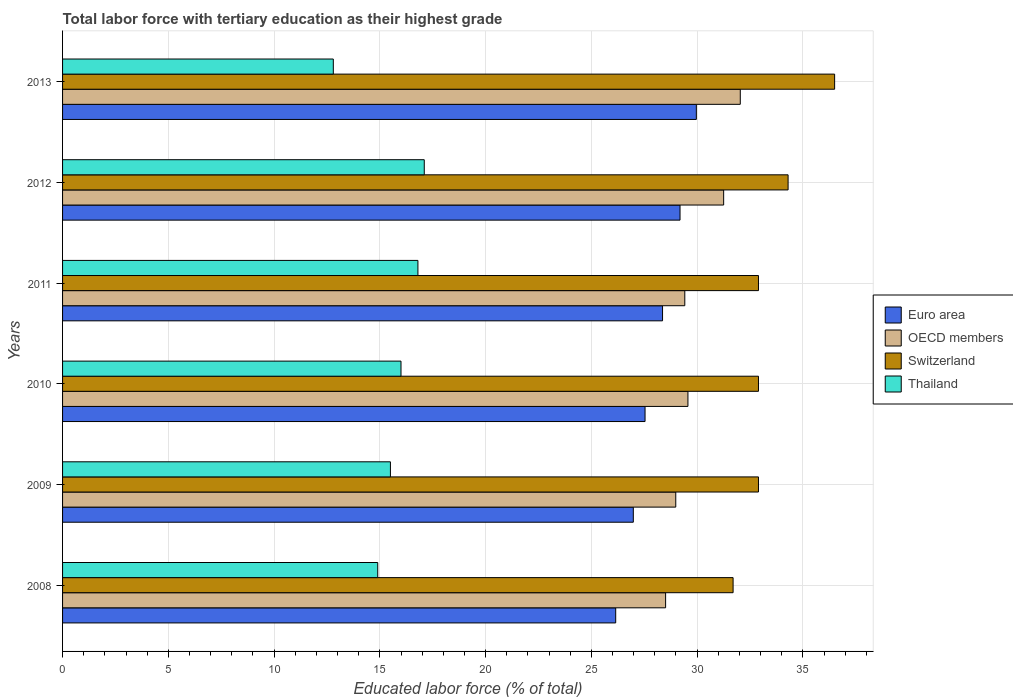How many groups of bars are there?
Your answer should be compact. 6. Are the number of bars on each tick of the Y-axis equal?
Offer a terse response. Yes. How many bars are there on the 6th tick from the top?
Ensure brevity in your answer.  4. How many bars are there on the 2nd tick from the bottom?
Provide a succinct answer. 4. What is the label of the 1st group of bars from the top?
Offer a terse response. 2013. What is the percentage of male labor force with tertiary education in Thailand in 2012?
Your response must be concise. 17.1. Across all years, what is the maximum percentage of male labor force with tertiary education in Thailand?
Keep it short and to the point. 17.1. Across all years, what is the minimum percentage of male labor force with tertiary education in Switzerland?
Give a very brief answer. 31.7. In which year was the percentage of male labor force with tertiary education in Thailand minimum?
Give a very brief answer. 2013. What is the total percentage of male labor force with tertiary education in Euro area in the graph?
Provide a short and direct response. 168.19. What is the difference between the percentage of male labor force with tertiary education in Switzerland in 2009 and that in 2011?
Provide a succinct answer. 0. What is the difference between the percentage of male labor force with tertiary education in Euro area in 2009 and the percentage of male labor force with tertiary education in OECD members in 2012?
Provide a succinct answer. -4.27. What is the average percentage of male labor force with tertiary education in Euro area per year?
Your response must be concise. 28.03. In the year 2011, what is the difference between the percentage of male labor force with tertiary education in Switzerland and percentage of male labor force with tertiary education in Euro area?
Keep it short and to the point. 4.54. In how many years, is the percentage of male labor force with tertiary education in Euro area greater than 21 %?
Your response must be concise. 6. What is the ratio of the percentage of male labor force with tertiary education in OECD members in 2008 to that in 2012?
Give a very brief answer. 0.91. Is the difference between the percentage of male labor force with tertiary education in Switzerland in 2008 and 2009 greater than the difference between the percentage of male labor force with tertiary education in Euro area in 2008 and 2009?
Keep it short and to the point. No. What is the difference between the highest and the second highest percentage of male labor force with tertiary education in Switzerland?
Keep it short and to the point. 2.2. What is the difference between the highest and the lowest percentage of male labor force with tertiary education in Thailand?
Offer a very short reply. 4.3. In how many years, is the percentage of male labor force with tertiary education in OECD members greater than the average percentage of male labor force with tertiary education in OECD members taken over all years?
Give a very brief answer. 2. Is it the case that in every year, the sum of the percentage of male labor force with tertiary education in Switzerland and percentage of male labor force with tertiary education in OECD members is greater than the sum of percentage of male labor force with tertiary education in Thailand and percentage of male labor force with tertiary education in Euro area?
Ensure brevity in your answer.  Yes. What does the 2nd bar from the top in 2010 represents?
Your answer should be very brief. Switzerland. Are all the bars in the graph horizontal?
Keep it short and to the point. Yes. How many years are there in the graph?
Provide a short and direct response. 6. Are the values on the major ticks of X-axis written in scientific E-notation?
Your answer should be very brief. No. Does the graph contain grids?
Offer a terse response. Yes. Where does the legend appear in the graph?
Keep it short and to the point. Center right. How are the legend labels stacked?
Offer a terse response. Vertical. What is the title of the graph?
Provide a succinct answer. Total labor force with tertiary education as their highest grade. What is the label or title of the X-axis?
Give a very brief answer. Educated labor force (% of total). What is the label or title of the Y-axis?
Your answer should be compact. Years. What is the Educated labor force (% of total) of Euro area in 2008?
Provide a short and direct response. 26.15. What is the Educated labor force (% of total) in OECD members in 2008?
Keep it short and to the point. 28.51. What is the Educated labor force (% of total) in Switzerland in 2008?
Offer a very short reply. 31.7. What is the Educated labor force (% of total) in Thailand in 2008?
Make the answer very short. 14.9. What is the Educated labor force (% of total) in Euro area in 2009?
Your response must be concise. 26.98. What is the Educated labor force (% of total) of OECD members in 2009?
Keep it short and to the point. 28.99. What is the Educated labor force (% of total) in Switzerland in 2009?
Keep it short and to the point. 32.9. What is the Educated labor force (% of total) in Thailand in 2009?
Provide a succinct answer. 15.5. What is the Educated labor force (% of total) in Euro area in 2010?
Keep it short and to the point. 27.54. What is the Educated labor force (% of total) of OECD members in 2010?
Your answer should be compact. 29.57. What is the Educated labor force (% of total) of Switzerland in 2010?
Provide a short and direct response. 32.9. What is the Educated labor force (% of total) of Thailand in 2010?
Offer a terse response. 16. What is the Educated labor force (% of total) in Euro area in 2011?
Offer a terse response. 28.36. What is the Educated labor force (% of total) of OECD members in 2011?
Offer a terse response. 29.42. What is the Educated labor force (% of total) in Switzerland in 2011?
Provide a short and direct response. 32.9. What is the Educated labor force (% of total) in Thailand in 2011?
Keep it short and to the point. 16.8. What is the Educated labor force (% of total) in Euro area in 2012?
Give a very brief answer. 29.19. What is the Educated labor force (% of total) of OECD members in 2012?
Give a very brief answer. 31.25. What is the Educated labor force (% of total) of Switzerland in 2012?
Provide a short and direct response. 34.3. What is the Educated labor force (% of total) in Thailand in 2012?
Keep it short and to the point. 17.1. What is the Educated labor force (% of total) of Euro area in 2013?
Offer a terse response. 29.96. What is the Educated labor force (% of total) of OECD members in 2013?
Give a very brief answer. 32.04. What is the Educated labor force (% of total) in Switzerland in 2013?
Keep it short and to the point. 36.5. What is the Educated labor force (% of total) of Thailand in 2013?
Provide a short and direct response. 12.8. Across all years, what is the maximum Educated labor force (% of total) of Euro area?
Provide a short and direct response. 29.96. Across all years, what is the maximum Educated labor force (% of total) of OECD members?
Your answer should be compact. 32.04. Across all years, what is the maximum Educated labor force (% of total) in Switzerland?
Keep it short and to the point. 36.5. Across all years, what is the maximum Educated labor force (% of total) of Thailand?
Offer a very short reply. 17.1. Across all years, what is the minimum Educated labor force (% of total) of Euro area?
Provide a short and direct response. 26.15. Across all years, what is the minimum Educated labor force (% of total) in OECD members?
Make the answer very short. 28.51. Across all years, what is the minimum Educated labor force (% of total) in Switzerland?
Provide a short and direct response. 31.7. Across all years, what is the minimum Educated labor force (% of total) of Thailand?
Your answer should be very brief. 12.8. What is the total Educated labor force (% of total) in Euro area in the graph?
Provide a short and direct response. 168.19. What is the total Educated labor force (% of total) in OECD members in the graph?
Offer a very short reply. 179.77. What is the total Educated labor force (% of total) of Switzerland in the graph?
Ensure brevity in your answer.  201.2. What is the total Educated labor force (% of total) of Thailand in the graph?
Make the answer very short. 93.1. What is the difference between the Educated labor force (% of total) of Euro area in 2008 and that in 2009?
Make the answer very short. -0.83. What is the difference between the Educated labor force (% of total) of OECD members in 2008 and that in 2009?
Provide a short and direct response. -0.48. What is the difference between the Educated labor force (% of total) of Euro area in 2008 and that in 2010?
Offer a very short reply. -1.39. What is the difference between the Educated labor force (% of total) in OECD members in 2008 and that in 2010?
Offer a very short reply. -1.06. What is the difference between the Educated labor force (% of total) of Euro area in 2008 and that in 2011?
Your answer should be very brief. -2.21. What is the difference between the Educated labor force (% of total) of OECD members in 2008 and that in 2011?
Make the answer very short. -0.91. What is the difference between the Educated labor force (% of total) in Switzerland in 2008 and that in 2011?
Ensure brevity in your answer.  -1.2. What is the difference between the Educated labor force (% of total) in Euro area in 2008 and that in 2012?
Offer a terse response. -3.04. What is the difference between the Educated labor force (% of total) of OECD members in 2008 and that in 2012?
Ensure brevity in your answer.  -2.74. What is the difference between the Educated labor force (% of total) of Thailand in 2008 and that in 2012?
Your response must be concise. -2.2. What is the difference between the Educated labor force (% of total) of Euro area in 2008 and that in 2013?
Your response must be concise. -3.81. What is the difference between the Educated labor force (% of total) in OECD members in 2008 and that in 2013?
Your response must be concise. -3.53. What is the difference between the Educated labor force (% of total) in Thailand in 2008 and that in 2013?
Make the answer very short. 2.1. What is the difference between the Educated labor force (% of total) in Euro area in 2009 and that in 2010?
Your answer should be very brief. -0.56. What is the difference between the Educated labor force (% of total) of OECD members in 2009 and that in 2010?
Keep it short and to the point. -0.58. What is the difference between the Educated labor force (% of total) of Switzerland in 2009 and that in 2010?
Provide a short and direct response. 0. What is the difference between the Educated labor force (% of total) of Thailand in 2009 and that in 2010?
Give a very brief answer. -0.5. What is the difference between the Educated labor force (% of total) of Euro area in 2009 and that in 2011?
Your answer should be very brief. -1.38. What is the difference between the Educated labor force (% of total) in OECD members in 2009 and that in 2011?
Provide a succinct answer. -0.43. What is the difference between the Educated labor force (% of total) in Switzerland in 2009 and that in 2011?
Make the answer very short. 0. What is the difference between the Educated labor force (% of total) in Euro area in 2009 and that in 2012?
Give a very brief answer. -2.21. What is the difference between the Educated labor force (% of total) in OECD members in 2009 and that in 2012?
Your response must be concise. -2.26. What is the difference between the Educated labor force (% of total) in Euro area in 2009 and that in 2013?
Provide a succinct answer. -2.98. What is the difference between the Educated labor force (% of total) of OECD members in 2009 and that in 2013?
Keep it short and to the point. -3.05. What is the difference between the Educated labor force (% of total) in Switzerland in 2009 and that in 2013?
Your answer should be very brief. -3.6. What is the difference between the Educated labor force (% of total) of Thailand in 2009 and that in 2013?
Your response must be concise. 2.7. What is the difference between the Educated labor force (% of total) of Euro area in 2010 and that in 2011?
Give a very brief answer. -0.83. What is the difference between the Educated labor force (% of total) in OECD members in 2010 and that in 2011?
Make the answer very short. 0.15. What is the difference between the Educated labor force (% of total) of Switzerland in 2010 and that in 2011?
Give a very brief answer. 0. What is the difference between the Educated labor force (% of total) in Thailand in 2010 and that in 2011?
Give a very brief answer. -0.8. What is the difference between the Educated labor force (% of total) in Euro area in 2010 and that in 2012?
Your answer should be very brief. -1.65. What is the difference between the Educated labor force (% of total) of OECD members in 2010 and that in 2012?
Offer a very short reply. -1.69. What is the difference between the Educated labor force (% of total) in Switzerland in 2010 and that in 2012?
Provide a succinct answer. -1.4. What is the difference between the Educated labor force (% of total) in Thailand in 2010 and that in 2012?
Provide a succinct answer. -1.1. What is the difference between the Educated labor force (% of total) of Euro area in 2010 and that in 2013?
Offer a very short reply. -2.42. What is the difference between the Educated labor force (% of total) of OECD members in 2010 and that in 2013?
Your answer should be compact. -2.47. What is the difference between the Educated labor force (% of total) of Switzerland in 2010 and that in 2013?
Your answer should be very brief. -3.6. What is the difference between the Educated labor force (% of total) of Euro area in 2011 and that in 2012?
Offer a terse response. -0.83. What is the difference between the Educated labor force (% of total) in OECD members in 2011 and that in 2012?
Your answer should be very brief. -1.84. What is the difference between the Educated labor force (% of total) in Switzerland in 2011 and that in 2012?
Offer a terse response. -1.4. What is the difference between the Educated labor force (% of total) of Euro area in 2011 and that in 2013?
Keep it short and to the point. -1.6. What is the difference between the Educated labor force (% of total) in OECD members in 2011 and that in 2013?
Offer a very short reply. -2.62. What is the difference between the Educated labor force (% of total) in Switzerland in 2011 and that in 2013?
Provide a succinct answer. -3.6. What is the difference between the Educated labor force (% of total) in Euro area in 2012 and that in 2013?
Offer a very short reply. -0.77. What is the difference between the Educated labor force (% of total) in OECD members in 2012 and that in 2013?
Offer a very short reply. -0.79. What is the difference between the Educated labor force (% of total) in Switzerland in 2012 and that in 2013?
Your answer should be compact. -2.2. What is the difference between the Educated labor force (% of total) of Thailand in 2012 and that in 2013?
Ensure brevity in your answer.  4.3. What is the difference between the Educated labor force (% of total) in Euro area in 2008 and the Educated labor force (% of total) in OECD members in 2009?
Give a very brief answer. -2.84. What is the difference between the Educated labor force (% of total) of Euro area in 2008 and the Educated labor force (% of total) of Switzerland in 2009?
Offer a terse response. -6.75. What is the difference between the Educated labor force (% of total) in Euro area in 2008 and the Educated labor force (% of total) in Thailand in 2009?
Keep it short and to the point. 10.65. What is the difference between the Educated labor force (% of total) of OECD members in 2008 and the Educated labor force (% of total) of Switzerland in 2009?
Keep it short and to the point. -4.39. What is the difference between the Educated labor force (% of total) of OECD members in 2008 and the Educated labor force (% of total) of Thailand in 2009?
Provide a succinct answer. 13.01. What is the difference between the Educated labor force (% of total) in Euro area in 2008 and the Educated labor force (% of total) in OECD members in 2010?
Your response must be concise. -3.42. What is the difference between the Educated labor force (% of total) of Euro area in 2008 and the Educated labor force (% of total) of Switzerland in 2010?
Provide a short and direct response. -6.75. What is the difference between the Educated labor force (% of total) of Euro area in 2008 and the Educated labor force (% of total) of Thailand in 2010?
Keep it short and to the point. 10.15. What is the difference between the Educated labor force (% of total) in OECD members in 2008 and the Educated labor force (% of total) in Switzerland in 2010?
Make the answer very short. -4.39. What is the difference between the Educated labor force (% of total) in OECD members in 2008 and the Educated labor force (% of total) in Thailand in 2010?
Provide a short and direct response. 12.51. What is the difference between the Educated labor force (% of total) in Euro area in 2008 and the Educated labor force (% of total) in OECD members in 2011?
Your answer should be very brief. -3.27. What is the difference between the Educated labor force (% of total) in Euro area in 2008 and the Educated labor force (% of total) in Switzerland in 2011?
Provide a succinct answer. -6.75. What is the difference between the Educated labor force (% of total) of Euro area in 2008 and the Educated labor force (% of total) of Thailand in 2011?
Your response must be concise. 9.35. What is the difference between the Educated labor force (% of total) of OECD members in 2008 and the Educated labor force (% of total) of Switzerland in 2011?
Make the answer very short. -4.39. What is the difference between the Educated labor force (% of total) of OECD members in 2008 and the Educated labor force (% of total) of Thailand in 2011?
Provide a short and direct response. 11.71. What is the difference between the Educated labor force (% of total) in Switzerland in 2008 and the Educated labor force (% of total) in Thailand in 2011?
Ensure brevity in your answer.  14.9. What is the difference between the Educated labor force (% of total) of Euro area in 2008 and the Educated labor force (% of total) of OECD members in 2012?
Make the answer very short. -5.1. What is the difference between the Educated labor force (% of total) in Euro area in 2008 and the Educated labor force (% of total) in Switzerland in 2012?
Your answer should be compact. -8.15. What is the difference between the Educated labor force (% of total) of Euro area in 2008 and the Educated labor force (% of total) of Thailand in 2012?
Ensure brevity in your answer.  9.05. What is the difference between the Educated labor force (% of total) of OECD members in 2008 and the Educated labor force (% of total) of Switzerland in 2012?
Your response must be concise. -5.79. What is the difference between the Educated labor force (% of total) of OECD members in 2008 and the Educated labor force (% of total) of Thailand in 2012?
Your response must be concise. 11.41. What is the difference between the Educated labor force (% of total) in Euro area in 2008 and the Educated labor force (% of total) in OECD members in 2013?
Make the answer very short. -5.89. What is the difference between the Educated labor force (% of total) in Euro area in 2008 and the Educated labor force (% of total) in Switzerland in 2013?
Offer a terse response. -10.35. What is the difference between the Educated labor force (% of total) in Euro area in 2008 and the Educated labor force (% of total) in Thailand in 2013?
Give a very brief answer. 13.35. What is the difference between the Educated labor force (% of total) of OECD members in 2008 and the Educated labor force (% of total) of Switzerland in 2013?
Your response must be concise. -7.99. What is the difference between the Educated labor force (% of total) in OECD members in 2008 and the Educated labor force (% of total) in Thailand in 2013?
Offer a terse response. 15.71. What is the difference between the Educated labor force (% of total) of Euro area in 2009 and the Educated labor force (% of total) of OECD members in 2010?
Make the answer very short. -2.58. What is the difference between the Educated labor force (% of total) of Euro area in 2009 and the Educated labor force (% of total) of Switzerland in 2010?
Give a very brief answer. -5.92. What is the difference between the Educated labor force (% of total) of Euro area in 2009 and the Educated labor force (% of total) of Thailand in 2010?
Keep it short and to the point. 10.98. What is the difference between the Educated labor force (% of total) of OECD members in 2009 and the Educated labor force (% of total) of Switzerland in 2010?
Your answer should be very brief. -3.91. What is the difference between the Educated labor force (% of total) of OECD members in 2009 and the Educated labor force (% of total) of Thailand in 2010?
Offer a very short reply. 12.99. What is the difference between the Educated labor force (% of total) of Switzerland in 2009 and the Educated labor force (% of total) of Thailand in 2010?
Your answer should be very brief. 16.9. What is the difference between the Educated labor force (% of total) in Euro area in 2009 and the Educated labor force (% of total) in OECD members in 2011?
Your answer should be very brief. -2.43. What is the difference between the Educated labor force (% of total) of Euro area in 2009 and the Educated labor force (% of total) of Switzerland in 2011?
Offer a very short reply. -5.92. What is the difference between the Educated labor force (% of total) in Euro area in 2009 and the Educated labor force (% of total) in Thailand in 2011?
Keep it short and to the point. 10.18. What is the difference between the Educated labor force (% of total) of OECD members in 2009 and the Educated labor force (% of total) of Switzerland in 2011?
Provide a succinct answer. -3.91. What is the difference between the Educated labor force (% of total) of OECD members in 2009 and the Educated labor force (% of total) of Thailand in 2011?
Your response must be concise. 12.19. What is the difference between the Educated labor force (% of total) in Euro area in 2009 and the Educated labor force (% of total) in OECD members in 2012?
Offer a very short reply. -4.27. What is the difference between the Educated labor force (% of total) of Euro area in 2009 and the Educated labor force (% of total) of Switzerland in 2012?
Provide a short and direct response. -7.32. What is the difference between the Educated labor force (% of total) in Euro area in 2009 and the Educated labor force (% of total) in Thailand in 2012?
Your answer should be compact. 9.88. What is the difference between the Educated labor force (% of total) in OECD members in 2009 and the Educated labor force (% of total) in Switzerland in 2012?
Provide a short and direct response. -5.31. What is the difference between the Educated labor force (% of total) of OECD members in 2009 and the Educated labor force (% of total) of Thailand in 2012?
Give a very brief answer. 11.89. What is the difference between the Educated labor force (% of total) in Switzerland in 2009 and the Educated labor force (% of total) in Thailand in 2012?
Provide a short and direct response. 15.8. What is the difference between the Educated labor force (% of total) of Euro area in 2009 and the Educated labor force (% of total) of OECD members in 2013?
Make the answer very short. -5.06. What is the difference between the Educated labor force (% of total) in Euro area in 2009 and the Educated labor force (% of total) in Switzerland in 2013?
Make the answer very short. -9.52. What is the difference between the Educated labor force (% of total) in Euro area in 2009 and the Educated labor force (% of total) in Thailand in 2013?
Your response must be concise. 14.18. What is the difference between the Educated labor force (% of total) in OECD members in 2009 and the Educated labor force (% of total) in Switzerland in 2013?
Ensure brevity in your answer.  -7.51. What is the difference between the Educated labor force (% of total) of OECD members in 2009 and the Educated labor force (% of total) of Thailand in 2013?
Your answer should be very brief. 16.19. What is the difference between the Educated labor force (% of total) in Switzerland in 2009 and the Educated labor force (% of total) in Thailand in 2013?
Your answer should be compact. 20.1. What is the difference between the Educated labor force (% of total) in Euro area in 2010 and the Educated labor force (% of total) in OECD members in 2011?
Provide a succinct answer. -1.88. What is the difference between the Educated labor force (% of total) of Euro area in 2010 and the Educated labor force (% of total) of Switzerland in 2011?
Make the answer very short. -5.36. What is the difference between the Educated labor force (% of total) in Euro area in 2010 and the Educated labor force (% of total) in Thailand in 2011?
Provide a succinct answer. 10.74. What is the difference between the Educated labor force (% of total) in OECD members in 2010 and the Educated labor force (% of total) in Switzerland in 2011?
Your answer should be very brief. -3.33. What is the difference between the Educated labor force (% of total) in OECD members in 2010 and the Educated labor force (% of total) in Thailand in 2011?
Ensure brevity in your answer.  12.77. What is the difference between the Educated labor force (% of total) in Euro area in 2010 and the Educated labor force (% of total) in OECD members in 2012?
Your answer should be compact. -3.72. What is the difference between the Educated labor force (% of total) of Euro area in 2010 and the Educated labor force (% of total) of Switzerland in 2012?
Offer a very short reply. -6.76. What is the difference between the Educated labor force (% of total) in Euro area in 2010 and the Educated labor force (% of total) in Thailand in 2012?
Offer a terse response. 10.44. What is the difference between the Educated labor force (% of total) of OECD members in 2010 and the Educated labor force (% of total) of Switzerland in 2012?
Make the answer very short. -4.73. What is the difference between the Educated labor force (% of total) of OECD members in 2010 and the Educated labor force (% of total) of Thailand in 2012?
Offer a terse response. 12.47. What is the difference between the Educated labor force (% of total) in Euro area in 2010 and the Educated labor force (% of total) in OECD members in 2013?
Provide a succinct answer. -4.5. What is the difference between the Educated labor force (% of total) in Euro area in 2010 and the Educated labor force (% of total) in Switzerland in 2013?
Offer a terse response. -8.96. What is the difference between the Educated labor force (% of total) of Euro area in 2010 and the Educated labor force (% of total) of Thailand in 2013?
Ensure brevity in your answer.  14.74. What is the difference between the Educated labor force (% of total) of OECD members in 2010 and the Educated labor force (% of total) of Switzerland in 2013?
Your answer should be compact. -6.93. What is the difference between the Educated labor force (% of total) in OECD members in 2010 and the Educated labor force (% of total) in Thailand in 2013?
Offer a terse response. 16.77. What is the difference between the Educated labor force (% of total) of Switzerland in 2010 and the Educated labor force (% of total) of Thailand in 2013?
Provide a succinct answer. 20.1. What is the difference between the Educated labor force (% of total) of Euro area in 2011 and the Educated labor force (% of total) of OECD members in 2012?
Your answer should be very brief. -2.89. What is the difference between the Educated labor force (% of total) of Euro area in 2011 and the Educated labor force (% of total) of Switzerland in 2012?
Provide a succinct answer. -5.94. What is the difference between the Educated labor force (% of total) of Euro area in 2011 and the Educated labor force (% of total) of Thailand in 2012?
Offer a terse response. 11.26. What is the difference between the Educated labor force (% of total) in OECD members in 2011 and the Educated labor force (% of total) in Switzerland in 2012?
Ensure brevity in your answer.  -4.88. What is the difference between the Educated labor force (% of total) of OECD members in 2011 and the Educated labor force (% of total) of Thailand in 2012?
Offer a very short reply. 12.32. What is the difference between the Educated labor force (% of total) of Switzerland in 2011 and the Educated labor force (% of total) of Thailand in 2012?
Make the answer very short. 15.8. What is the difference between the Educated labor force (% of total) in Euro area in 2011 and the Educated labor force (% of total) in OECD members in 2013?
Ensure brevity in your answer.  -3.67. What is the difference between the Educated labor force (% of total) in Euro area in 2011 and the Educated labor force (% of total) in Switzerland in 2013?
Provide a short and direct response. -8.14. What is the difference between the Educated labor force (% of total) in Euro area in 2011 and the Educated labor force (% of total) in Thailand in 2013?
Keep it short and to the point. 15.56. What is the difference between the Educated labor force (% of total) of OECD members in 2011 and the Educated labor force (% of total) of Switzerland in 2013?
Give a very brief answer. -7.08. What is the difference between the Educated labor force (% of total) in OECD members in 2011 and the Educated labor force (% of total) in Thailand in 2013?
Your answer should be very brief. 16.62. What is the difference between the Educated labor force (% of total) of Switzerland in 2011 and the Educated labor force (% of total) of Thailand in 2013?
Offer a very short reply. 20.1. What is the difference between the Educated labor force (% of total) of Euro area in 2012 and the Educated labor force (% of total) of OECD members in 2013?
Give a very brief answer. -2.85. What is the difference between the Educated labor force (% of total) in Euro area in 2012 and the Educated labor force (% of total) in Switzerland in 2013?
Keep it short and to the point. -7.31. What is the difference between the Educated labor force (% of total) in Euro area in 2012 and the Educated labor force (% of total) in Thailand in 2013?
Offer a very short reply. 16.39. What is the difference between the Educated labor force (% of total) of OECD members in 2012 and the Educated labor force (% of total) of Switzerland in 2013?
Give a very brief answer. -5.25. What is the difference between the Educated labor force (% of total) in OECD members in 2012 and the Educated labor force (% of total) in Thailand in 2013?
Give a very brief answer. 18.45. What is the average Educated labor force (% of total) of Euro area per year?
Give a very brief answer. 28.03. What is the average Educated labor force (% of total) in OECD members per year?
Ensure brevity in your answer.  29.96. What is the average Educated labor force (% of total) in Switzerland per year?
Keep it short and to the point. 33.53. What is the average Educated labor force (% of total) in Thailand per year?
Keep it short and to the point. 15.52. In the year 2008, what is the difference between the Educated labor force (% of total) in Euro area and Educated labor force (% of total) in OECD members?
Provide a short and direct response. -2.36. In the year 2008, what is the difference between the Educated labor force (% of total) in Euro area and Educated labor force (% of total) in Switzerland?
Offer a very short reply. -5.55. In the year 2008, what is the difference between the Educated labor force (% of total) of Euro area and Educated labor force (% of total) of Thailand?
Give a very brief answer. 11.25. In the year 2008, what is the difference between the Educated labor force (% of total) in OECD members and Educated labor force (% of total) in Switzerland?
Your answer should be compact. -3.19. In the year 2008, what is the difference between the Educated labor force (% of total) of OECD members and Educated labor force (% of total) of Thailand?
Your answer should be compact. 13.61. In the year 2008, what is the difference between the Educated labor force (% of total) in Switzerland and Educated labor force (% of total) in Thailand?
Provide a short and direct response. 16.8. In the year 2009, what is the difference between the Educated labor force (% of total) of Euro area and Educated labor force (% of total) of OECD members?
Your answer should be compact. -2.01. In the year 2009, what is the difference between the Educated labor force (% of total) in Euro area and Educated labor force (% of total) in Switzerland?
Offer a very short reply. -5.92. In the year 2009, what is the difference between the Educated labor force (% of total) of Euro area and Educated labor force (% of total) of Thailand?
Provide a short and direct response. 11.48. In the year 2009, what is the difference between the Educated labor force (% of total) in OECD members and Educated labor force (% of total) in Switzerland?
Your answer should be very brief. -3.91. In the year 2009, what is the difference between the Educated labor force (% of total) of OECD members and Educated labor force (% of total) of Thailand?
Offer a terse response. 13.49. In the year 2009, what is the difference between the Educated labor force (% of total) in Switzerland and Educated labor force (% of total) in Thailand?
Provide a succinct answer. 17.4. In the year 2010, what is the difference between the Educated labor force (% of total) of Euro area and Educated labor force (% of total) of OECD members?
Your answer should be compact. -2.03. In the year 2010, what is the difference between the Educated labor force (% of total) in Euro area and Educated labor force (% of total) in Switzerland?
Give a very brief answer. -5.36. In the year 2010, what is the difference between the Educated labor force (% of total) in Euro area and Educated labor force (% of total) in Thailand?
Keep it short and to the point. 11.54. In the year 2010, what is the difference between the Educated labor force (% of total) of OECD members and Educated labor force (% of total) of Switzerland?
Your response must be concise. -3.33. In the year 2010, what is the difference between the Educated labor force (% of total) of OECD members and Educated labor force (% of total) of Thailand?
Your answer should be very brief. 13.57. In the year 2010, what is the difference between the Educated labor force (% of total) of Switzerland and Educated labor force (% of total) of Thailand?
Your response must be concise. 16.9. In the year 2011, what is the difference between the Educated labor force (% of total) of Euro area and Educated labor force (% of total) of OECD members?
Offer a terse response. -1.05. In the year 2011, what is the difference between the Educated labor force (% of total) in Euro area and Educated labor force (% of total) in Switzerland?
Make the answer very short. -4.54. In the year 2011, what is the difference between the Educated labor force (% of total) in Euro area and Educated labor force (% of total) in Thailand?
Offer a very short reply. 11.56. In the year 2011, what is the difference between the Educated labor force (% of total) of OECD members and Educated labor force (% of total) of Switzerland?
Provide a succinct answer. -3.48. In the year 2011, what is the difference between the Educated labor force (% of total) in OECD members and Educated labor force (% of total) in Thailand?
Offer a terse response. 12.62. In the year 2012, what is the difference between the Educated labor force (% of total) in Euro area and Educated labor force (% of total) in OECD members?
Provide a short and direct response. -2.06. In the year 2012, what is the difference between the Educated labor force (% of total) of Euro area and Educated labor force (% of total) of Switzerland?
Provide a short and direct response. -5.11. In the year 2012, what is the difference between the Educated labor force (% of total) of Euro area and Educated labor force (% of total) of Thailand?
Your answer should be very brief. 12.09. In the year 2012, what is the difference between the Educated labor force (% of total) of OECD members and Educated labor force (% of total) of Switzerland?
Offer a very short reply. -3.05. In the year 2012, what is the difference between the Educated labor force (% of total) in OECD members and Educated labor force (% of total) in Thailand?
Offer a very short reply. 14.15. In the year 2012, what is the difference between the Educated labor force (% of total) of Switzerland and Educated labor force (% of total) of Thailand?
Provide a succinct answer. 17.2. In the year 2013, what is the difference between the Educated labor force (% of total) of Euro area and Educated labor force (% of total) of OECD members?
Provide a short and direct response. -2.08. In the year 2013, what is the difference between the Educated labor force (% of total) in Euro area and Educated labor force (% of total) in Switzerland?
Offer a very short reply. -6.54. In the year 2013, what is the difference between the Educated labor force (% of total) in Euro area and Educated labor force (% of total) in Thailand?
Your answer should be compact. 17.16. In the year 2013, what is the difference between the Educated labor force (% of total) in OECD members and Educated labor force (% of total) in Switzerland?
Provide a succinct answer. -4.46. In the year 2013, what is the difference between the Educated labor force (% of total) of OECD members and Educated labor force (% of total) of Thailand?
Provide a succinct answer. 19.24. In the year 2013, what is the difference between the Educated labor force (% of total) in Switzerland and Educated labor force (% of total) in Thailand?
Keep it short and to the point. 23.7. What is the ratio of the Educated labor force (% of total) of Euro area in 2008 to that in 2009?
Offer a terse response. 0.97. What is the ratio of the Educated labor force (% of total) in OECD members in 2008 to that in 2009?
Give a very brief answer. 0.98. What is the ratio of the Educated labor force (% of total) of Switzerland in 2008 to that in 2009?
Offer a terse response. 0.96. What is the ratio of the Educated labor force (% of total) in Thailand in 2008 to that in 2009?
Your answer should be compact. 0.96. What is the ratio of the Educated labor force (% of total) of Euro area in 2008 to that in 2010?
Make the answer very short. 0.95. What is the ratio of the Educated labor force (% of total) of OECD members in 2008 to that in 2010?
Make the answer very short. 0.96. What is the ratio of the Educated labor force (% of total) in Switzerland in 2008 to that in 2010?
Provide a short and direct response. 0.96. What is the ratio of the Educated labor force (% of total) in Thailand in 2008 to that in 2010?
Your answer should be compact. 0.93. What is the ratio of the Educated labor force (% of total) in Euro area in 2008 to that in 2011?
Your answer should be compact. 0.92. What is the ratio of the Educated labor force (% of total) in OECD members in 2008 to that in 2011?
Provide a succinct answer. 0.97. What is the ratio of the Educated labor force (% of total) of Switzerland in 2008 to that in 2011?
Provide a short and direct response. 0.96. What is the ratio of the Educated labor force (% of total) in Thailand in 2008 to that in 2011?
Provide a short and direct response. 0.89. What is the ratio of the Educated labor force (% of total) in Euro area in 2008 to that in 2012?
Give a very brief answer. 0.9. What is the ratio of the Educated labor force (% of total) of OECD members in 2008 to that in 2012?
Give a very brief answer. 0.91. What is the ratio of the Educated labor force (% of total) of Switzerland in 2008 to that in 2012?
Your response must be concise. 0.92. What is the ratio of the Educated labor force (% of total) in Thailand in 2008 to that in 2012?
Your response must be concise. 0.87. What is the ratio of the Educated labor force (% of total) in Euro area in 2008 to that in 2013?
Your answer should be compact. 0.87. What is the ratio of the Educated labor force (% of total) in OECD members in 2008 to that in 2013?
Your answer should be very brief. 0.89. What is the ratio of the Educated labor force (% of total) in Switzerland in 2008 to that in 2013?
Your answer should be compact. 0.87. What is the ratio of the Educated labor force (% of total) in Thailand in 2008 to that in 2013?
Ensure brevity in your answer.  1.16. What is the ratio of the Educated labor force (% of total) in Euro area in 2009 to that in 2010?
Give a very brief answer. 0.98. What is the ratio of the Educated labor force (% of total) of OECD members in 2009 to that in 2010?
Your response must be concise. 0.98. What is the ratio of the Educated labor force (% of total) of Thailand in 2009 to that in 2010?
Provide a succinct answer. 0.97. What is the ratio of the Educated labor force (% of total) in Euro area in 2009 to that in 2011?
Your response must be concise. 0.95. What is the ratio of the Educated labor force (% of total) of OECD members in 2009 to that in 2011?
Ensure brevity in your answer.  0.99. What is the ratio of the Educated labor force (% of total) of Switzerland in 2009 to that in 2011?
Offer a very short reply. 1. What is the ratio of the Educated labor force (% of total) of Thailand in 2009 to that in 2011?
Keep it short and to the point. 0.92. What is the ratio of the Educated labor force (% of total) of Euro area in 2009 to that in 2012?
Provide a succinct answer. 0.92. What is the ratio of the Educated labor force (% of total) in OECD members in 2009 to that in 2012?
Your response must be concise. 0.93. What is the ratio of the Educated labor force (% of total) of Switzerland in 2009 to that in 2012?
Make the answer very short. 0.96. What is the ratio of the Educated labor force (% of total) in Thailand in 2009 to that in 2012?
Provide a short and direct response. 0.91. What is the ratio of the Educated labor force (% of total) of Euro area in 2009 to that in 2013?
Offer a terse response. 0.9. What is the ratio of the Educated labor force (% of total) in OECD members in 2009 to that in 2013?
Provide a short and direct response. 0.9. What is the ratio of the Educated labor force (% of total) of Switzerland in 2009 to that in 2013?
Your answer should be compact. 0.9. What is the ratio of the Educated labor force (% of total) in Thailand in 2009 to that in 2013?
Provide a succinct answer. 1.21. What is the ratio of the Educated labor force (% of total) of Euro area in 2010 to that in 2011?
Your answer should be very brief. 0.97. What is the ratio of the Educated labor force (% of total) of Euro area in 2010 to that in 2012?
Give a very brief answer. 0.94. What is the ratio of the Educated labor force (% of total) of OECD members in 2010 to that in 2012?
Provide a succinct answer. 0.95. What is the ratio of the Educated labor force (% of total) in Switzerland in 2010 to that in 2012?
Provide a short and direct response. 0.96. What is the ratio of the Educated labor force (% of total) in Thailand in 2010 to that in 2012?
Your response must be concise. 0.94. What is the ratio of the Educated labor force (% of total) in Euro area in 2010 to that in 2013?
Provide a short and direct response. 0.92. What is the ratio of the Educated labor force (% of total) in OECD members in 2010 to that in 2013?
Ensure brevity in your answer.  0.92. What is the ratio of the Educated labor force (% of total) of Switzerland in 2010 to that in 2013?
Provide a succinct answer. 0.9. What is the ratio of the Educated labor force (% of total) of Thailand in 2010 to that in 2013?
Offer a terse response. 1.25. What is the ratio of the Educated labor force (% of total) of Euro area in 2011 to that in 2012?
Offer a very short reply. 0.97. What is the ratio of the Educated labor force (% of total) in Switzerland in 2011 to that in 2012?
Give a very brief answer. 0.96. What is the ratio of the Educated labor force (% of total) of Thailand in 2011 to that in 2012?
Give a very brief answer. 0.98. What is the ratio of the Educated labor force (% of total) in Euro area in 2011 to that in 2013?
Provide a succinct answer. 0.95. What is the ratio of the Educated labor force (% of total) of OECD members in 2011 to that in 2013?
Provide a succinct answer. 0.92. What is the ratio of the Educated labor force (% of total) of Switzerland in 2011 to that in 2013?
Your answer should be compact. 0.9. What is the ratio of the Educated labor force (% of total) of Thailand in 2011 to that in 2013?
Your answer should be compact. 1.31. What is the ratio of the Educated labor force (% of total) of Euro area in 2012 to that in 2013?
Offer a very short reply. 0.97. What is the ratio of the Educated labor force (% of total) in OECD members in 2012 to that in 2013?
Provide a succinct answer. 0.98. What is the ratio of the Educated labor force (% of total) in Switzerland in 2012 to that in 2013?
Offer a terse response. 0.94. What is the ratio of the Educated labor force (% of total) in Thailand in 2012 to that in 2013?
Give a very brief answer. 1.34. What is the difference between the highest and the second highest Educated labor force (% of total) of Euro area?
Provide a succinct answer. 0.77. What is the difference between the highest and the second highest Educated labor force (% of total) of OECD members?
Your response must be concise. 0.79. What is the difference between the highest and the second highest Educated labor force (% of total) in Thailand?
Ensure brevity in your answer.  0.3. What is the difference between the highest and the lowest Educated labor force (% of total) in Euro area?
Provide a short and direct response. 3.81. What is the difference between the highest and the lowest Educated labor force (% of total) of OECD members?
Provide a succinct answer. 3.53. What is the difference between the highest and the lowest Educated labor force (% of total) of Switzerland?
Offer a terse response. 4.8. 